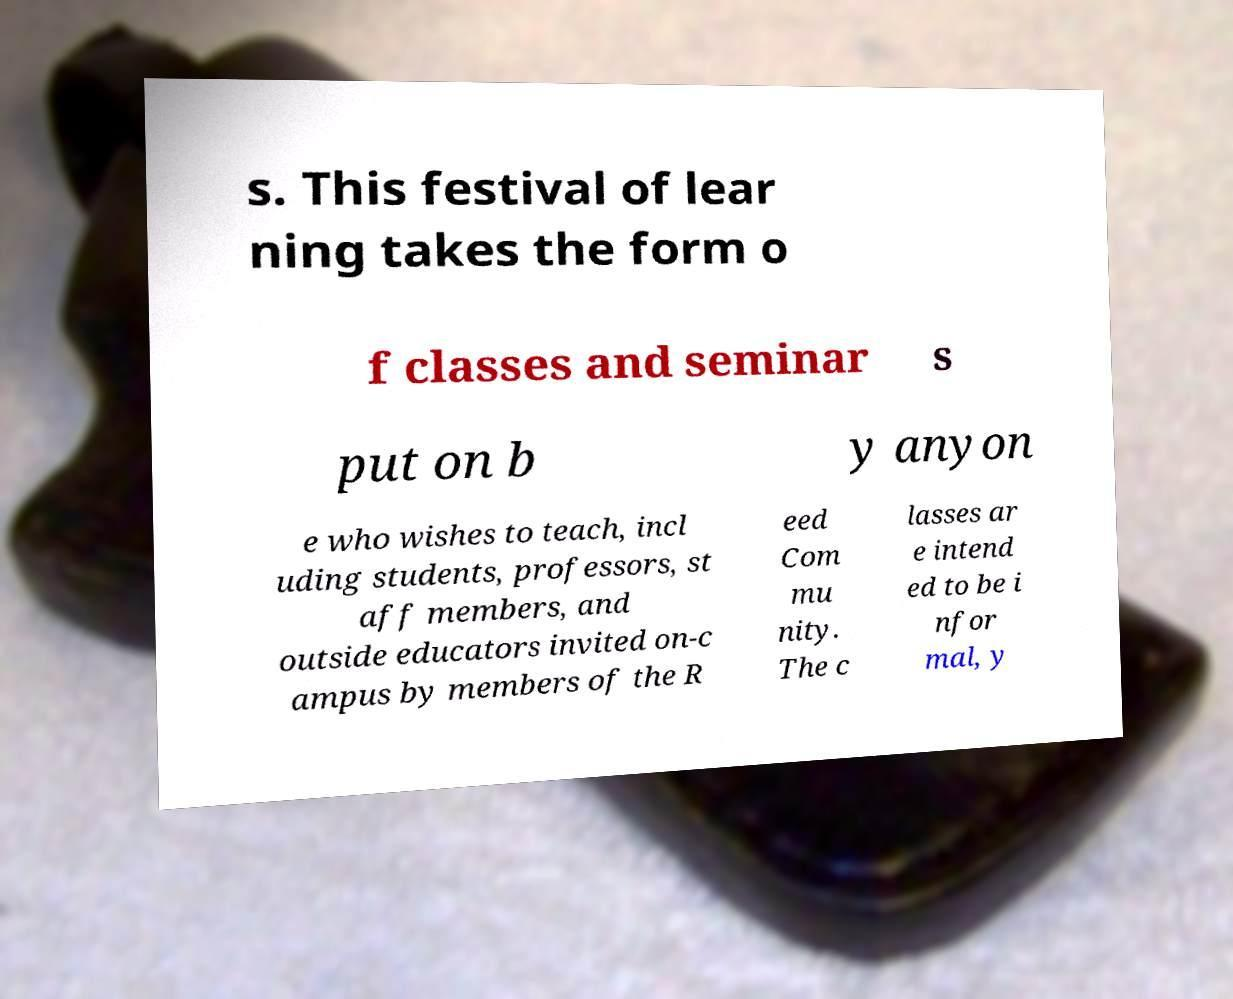Could you extract and type out the text from this image? s. This festival of lear ning takes the form o f classes and seminar s put on b y anyon e who wishes to teach, incl uding students, professors, st aff members, and outside educators invited on-c ampus by members of the R eed Com mu nity. The c lasses ar e intend ed to be i nfor mal, y 